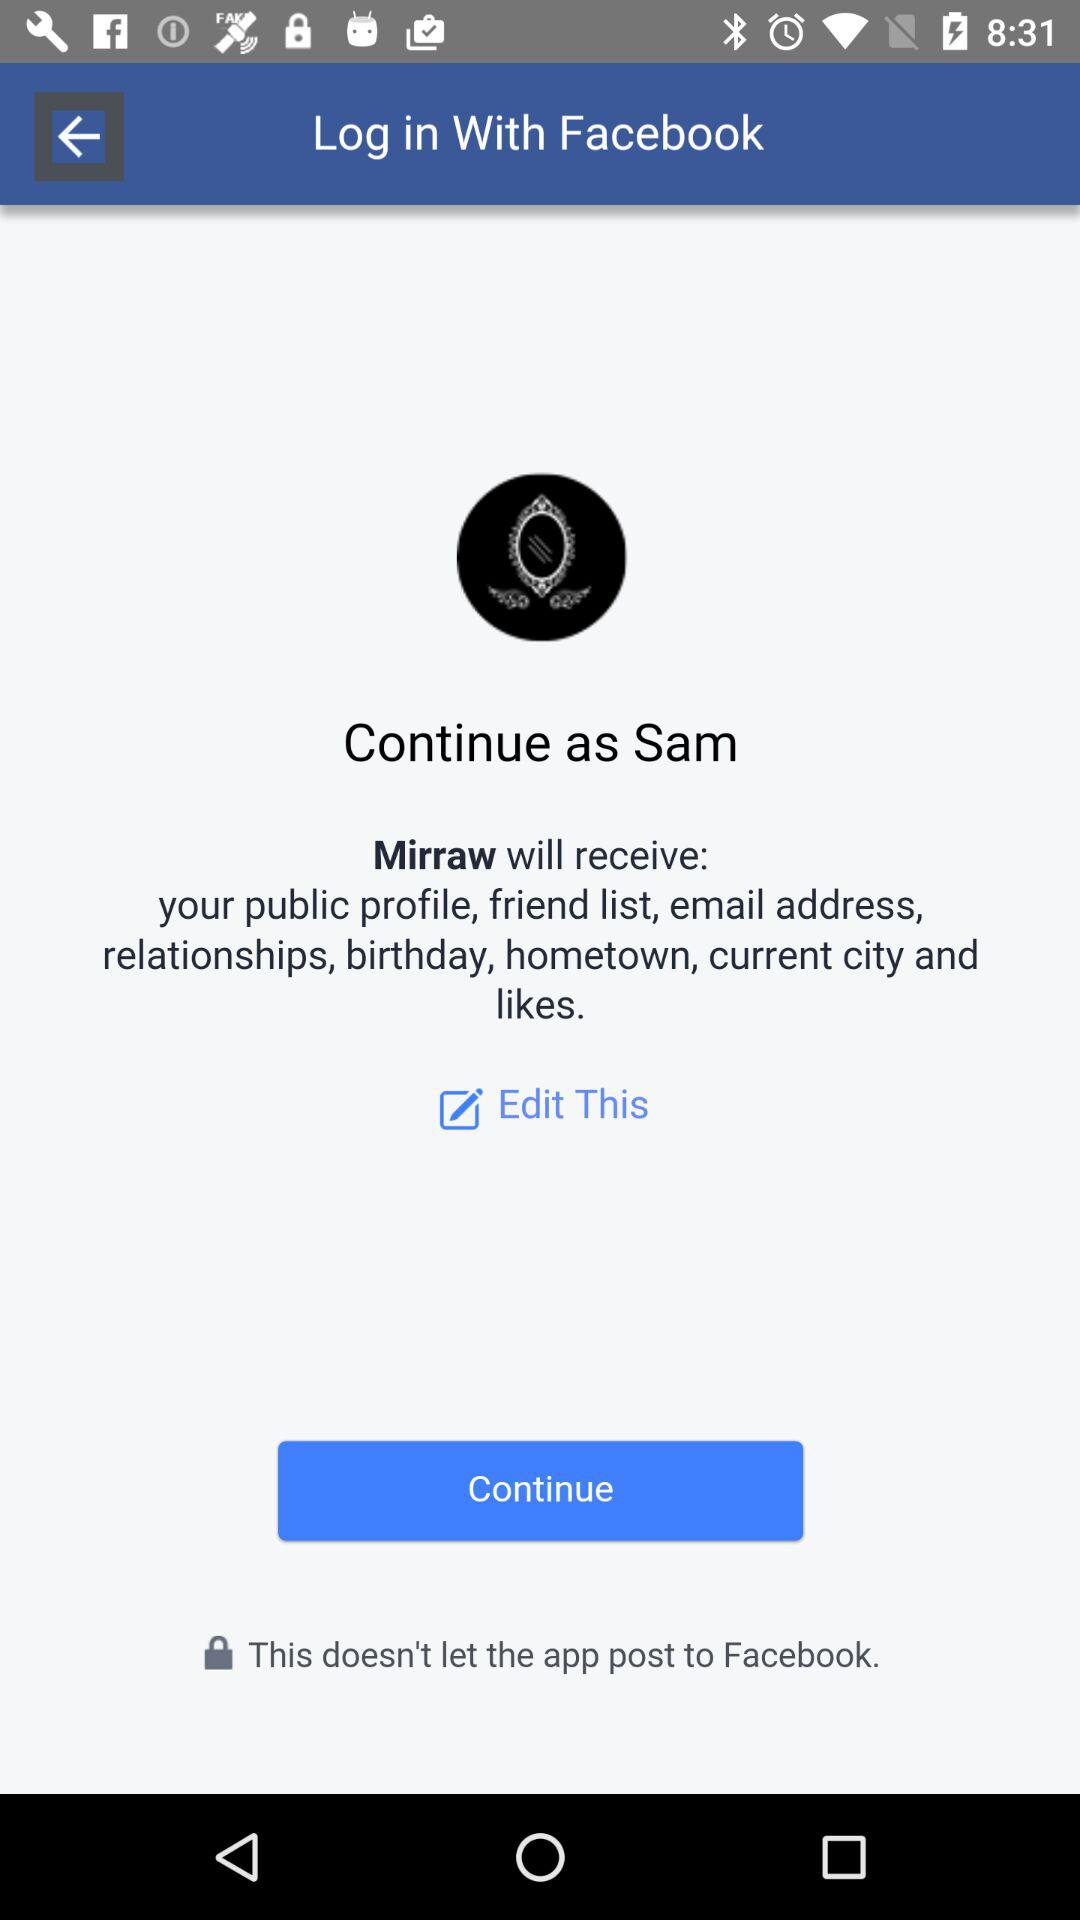What application is asking for permission? The application asking for permission is "Mirraw". 